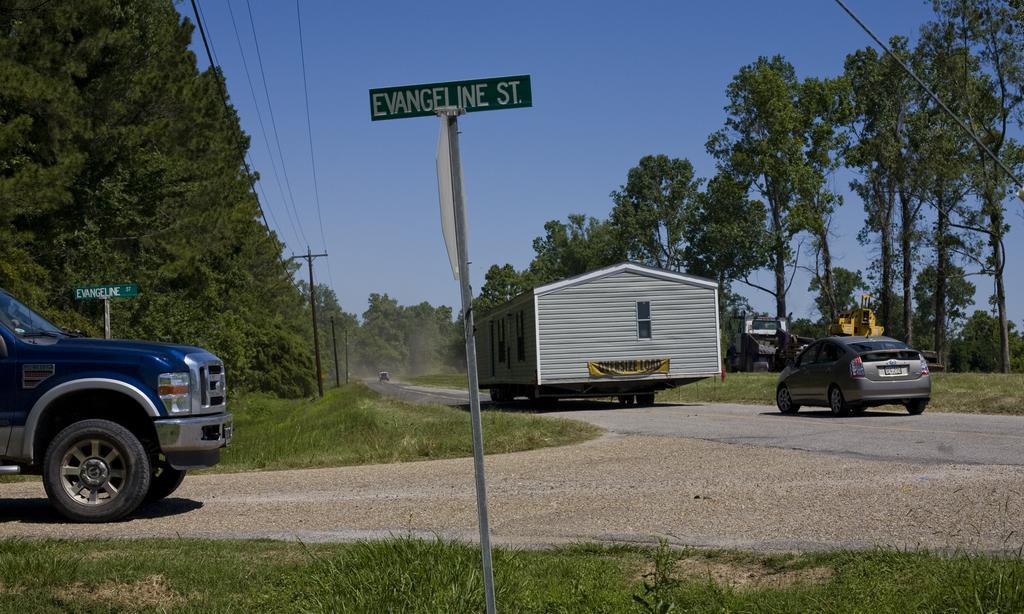Please provide a concise description of this image. In this image in the foreground we see a sign board, on the right side, I can see a car on the road, at the back, I can see many trees, and in the background I can see the sky. 